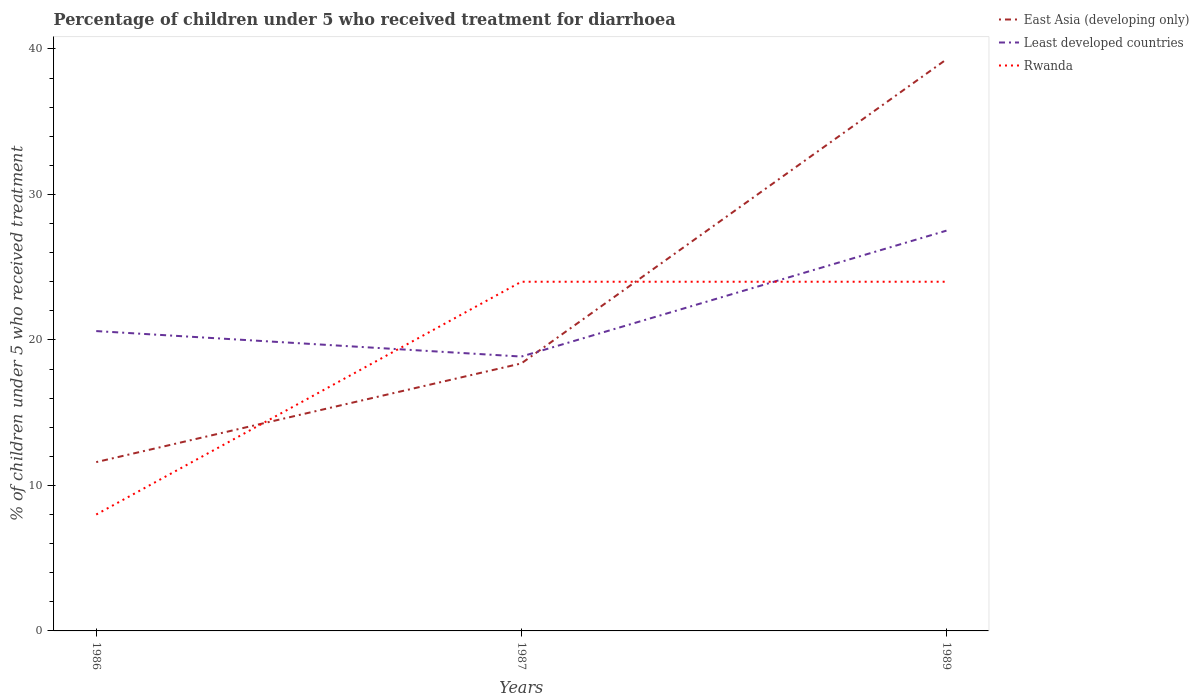Across all years, what is the maximum percentage of children who received treatment for diarrhoea  in Least developed countries?
Make the answer very short. 18.86. In which year was the percentage of children who received treatment for diarrhoea  in East Asia (developing only) maximum?
Ensure brevity in your answer.  1986. What is the total percentage of children who received treatment for diarrhoea  in Least developed countries in the graph?
Your response must be concise. 1.75. What is the difference between the highest and the second highest percentage of children who received treatment for diarrhoea  in Least developed countries?
Your response must be concise. 8.65. Is the percentage of children who received treatment for diarrhoea  in Rwanda strictly greater than the percentage of children who received treatment for diarrhoea  in East Asia (developing only) over the years?
Offer a terse response. No. How many lines are there?
Offer a terse response. 3. Does the graph contain any zero values?
Your answer should be compact. No. Does the graph contain grids?
Your response must be concise. No. Where does the legend appear in the graph?
Ensure brevity in your answer.  Top right. How many legend labels are there?
Ensure brevity in your answer.  3. How are the legend labels stacked?
Offer a terse response. Vertical. What is the title of the graph?
Provide a short and direct response. Percentage of children under 5 who received treatment for diarrhoea. What is the label or title of the Y-axis?
Provide a short and direct response. % of children under 5 who received treatment. What is the % of children under 5 who received treatment in East Asia (developing only) in 1986?
Your answer should be compact. 11.6. What is the % of children under 5 who received treatment in Least developed countries in 1986?
Provide a short and direct response. 20.61. What is the % of children under 5 who received treatment in East Asia (developing only) in 1987?
Your response must be concise. 18.39. What is the % of children under 5 who received treatment of Least developed countries in 1987?
Make the answer very short. 18.86. What is the % of children under 5 who received treatment in Rwanda in 1987?
Offer a terse response. 24. What is the % of children under 5 who received treatment in East Asia (developing only) in 1989?
Offer a terse response. 39.29. What is the % of children under 5 who received treatment in Least developed countries in 1989?
Your answer should be very brief. 27.51. What is the % of children under 5 who received treatment of Rwanda in 1989?
Keep it short and to the point. 24. Across all years, what is the maximum % of children under 5 who received treatment in East Asia (developing only)?
Keep it short and to the point. 39.29. Across all years, what is the maximum % of children under 5 who received treatment in Least developed countries?
Make the answer very short. 27.51. Across all years, what is the minimum % of children under 5 who received treatment in East Asia (developing only)?
Your response must be concise. 11.6. Across all years, what is the minimum % of children under 5 who received treatment in Least developed countries?
Offer a terse response. 18.86. What is the total % of children under 5 who received treatment in East Asia (developing only) in the graph?
Make the answer very short. 69.27. What is the total % of children under 5 who received treatment in Least developed countries in the graph?
Your answer should be very brief. 66.98. What is the total % of children under 5 who received treatment of Rwanda in the graph?
Ensure brevity in your answer.  56. What is the difference between the % of children under 5 who received treatment in East Asia (developing only) in 1986 and that in 1987?
Offer a terse response. -6.78. What is the difference between the % of children under 5 who received treatment of Least developed countries in 1986 and that in 1987?
Your answer should be compact. 1.75. What is the difference between the % of children under 5 who received treatment of Rwanda in 1986 and that in 1987?
Offer a very short reply. -16. What is the difference between the % of children under 5 who received treatment of East Asia (developing only) in 1986 and that in 1989?
Keep it short and to the point. -27.68. What is the difference between the % of children under 5 who received treatment of Least developed countries in 1986 and that in 1989?
Provide a short and direct response. -6.9. What is the difference between the % of children under 5 who received treatment in Rwanda in 1986 and that in 1989?
Your answer should be compact. -16. What is the difference between the % of children under 5 who received treatment in East Asia (developing only) in 1987 and that in 1989?
Make the answer very short. -20.9. What is the difference between the % of children under 5 who received treatment in Least developed countries in 1987 and that in 1989?
Provide a succinct answer. -8.65. What is the difference between the % of children under 5 who received treatment in East Asia (developing only) in 1986 and the % of children under 5 who received treatment in Least developed countries in 1987?
Ensure brevity in your answer.  -7.25. What is the difference between the % of children under 5 who received treatment in East Asia (developing only) in 1986 and the % of children under 5 who received treatment in Rwanda in 1987?
Ensure brevity in your answer.  -12.4. What is the difference between the % of children under 5 who received treatment of Least developed countries in 1986 and the % of children under 5 who received treatment of Rwanda in 1987?
Your response must be concise. -3.39. What is the difference between the % of children under 5 who received treatment in East Asia (developing only) in 1986 and the % of children under 5 who received treatment in Least developed countries in 1989?
Provide a succinct answer. -15.91. What is the difference between the % of children under 5 who received treatment of East Asia (developing only) in 1986 and the % of children under 5 who received treatment of Rwanda in 1989?
Your answer should be compact. -12.4. What is the difference between the % of children under 5 who received treatment of Least developed countries in 1986 and the % of children under 5 who received treatment of Rwanda in 1989?
Offer a very short reply. -3.39. What is the difference between the % of children under 5 who received treatment of East Asia (developing only) in 1987 and the % of children under 5 who received treatment of Least developed countries in 1989?
Offer a very short reply. -9.13. What is the difference between the % of children under 5 who received treatment in East Asia (developing only) in 1987 and the % of children under 5 who received treatment in Rwanda in 1989?
Offer a very short reply. -5.61. What is the difference between the % of children under 5 who received treatment of Least developed countries in 1987 and the % of children under 5 who received treatment of Rwanda in 1989?
Your response must be concise. -5.14. What is the average % of children under 5 who received treatment of East Asia (developing only) per year?
Ensure brevity in your answer.  23.09. What is the average % of children under 5 who received treatment of Least developed countries per year?
Provide a short and direct response. 22.33. What is the average % of children under 5 who received treatment in Rwanda per year?
Your answer should be compact. 18.67. In the year 1986, what is the difference between the % of children under 5 who received treatment of East Asia (developing only) and % of children under 5 who received treatment of Least developed countries?
Your response must be concise. -9.01. In the year 1986, what is the difference between the % of children under 5 who received treatment in East Asia (developing only) and % of children under 5 who received treatment in Rwanda?
Offer a very short reply. 3.6. In the year 1986, what is the difference between the % of children under 5 who received treatment of Least developed countries and % of children under 5 who received treatment of Rwanda?
Ensure brevity in your answer.  12.61. In the year 1987, what is the difference between the % of children under 5 who received treatment of East Asia (developing only) and % of children under 5 who received treatment of Least developed countries?
Offer a very short reply. -0.47. In the year 1987, what is the difference between the % of children under 5 who received treatment in East Asia (developing only) and % of children under 5 who received treatment in Rwanda?
Provide a succinct answer. -5.61. In the year 1987, what is the difference between the % of children under 5 who received treatment of Least developed countries and % of children under 5 who received treatment of Rwanda?
Provide a succinct answer. -5.14. In the year 1989, what is the difference between the % of children under 5 who received treatment of East Asia (developing only) and % of children under 5 who received treatment of Least developed countries?
Provide a succinct answer. 11.77. In the year 1989, what is the difference between the % of children under 5 who received treatment of East Asia (developing only) and % of children under 5 who received treatment of Rwanda?
Give a very brief answer. 15.29. In the year 1989, what is the difference between the % of children under 5 who received treatment in Least developed countries and % of children under 5 who received treatment in Rwanda?
Make the answer very short. 3.51. What is the ratio of the % of children under 5 who received treatment in East Asia (developing only) in 1986 to that in 1987?
Offer a very short reply. 0.63. What is the ratio of the % of children under 5 who received treatment of Least developed countries in 1986 to that in 1987?
Ensure brevity in your answer.  1.09. What is the ratio of the % of children under 5 who received treatment of East Asia (developing only) in 1986 to that in 1989?
Offer a very short reply. 0.3. What is the ratio of the % of children under 5 who received treatment in Least developed countries in 1986 to that in 1989?
Make the answer very short. 0.75. What is the ratio of the % of children under 5 who received treatment in Rwanda in 1986 to that in 1989?
Provide a short and direct response. 0.33. What is the ratio of the % of children under 5 who received treatment in East Asia (developing only) in 1987 to that in 1989?
Keep it short and to the point. 0.47. What is the ratio of the % of children under 5 who received treatment in Least developed countries in 1987 to that in 1989?
Provide a short and direct response. 0.69. What is the difference between the highest and the second highest % of children under 5 who received treatment in East Asia (developing only)?
Give a very brief answer. 20.9. What is the difference between the highest and the second highest % of children under 5 who received treatment of Least developed countries?
Offer a very short reply. 6.9. What is the difference between the highest and the lowest % of children under 5 who received treatment of East Asia (developing only)?
Your answer should be compact. 27.68. What is the difference between the highest and the lowest % of children under 5 who received treatment of Least developed countries?
Offer a terse response. 8.65. What is the difference between the highest and the lowest % of children under 5 who received treatment in Rwanda?
Ensure brevity in your answer.  16. 